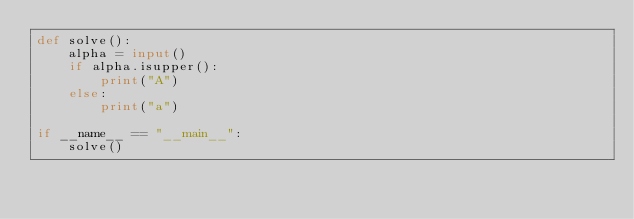<code> <loc_0><loc_0><loc_500><loc_500><_Python_>def solve():
    alpha = input()
    if alpha.isupper():
        print("A")
    else:
        print("a")

if __name__ == "__main__":
    solve()</code> 